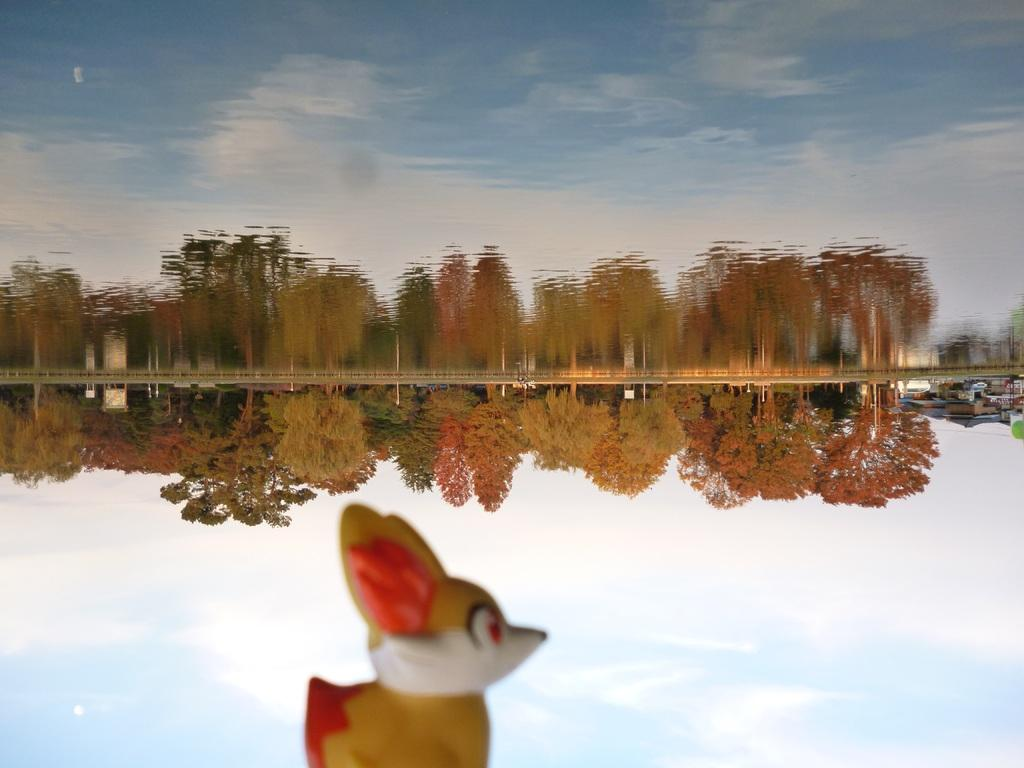What type of natural elements can be seen in the image? There are trees in the image. What type of man-made object is present in the image? There is a toy in the image. What can be observed in the water in the image? There are clouds, reflections of trees, reflections of clouds, and reflections of the sky in the water. What type of laborer is working on the boundary in the image? There is no laborer or boundary present in the image. Can you see a gun in the image? There is no gun present in the image. 